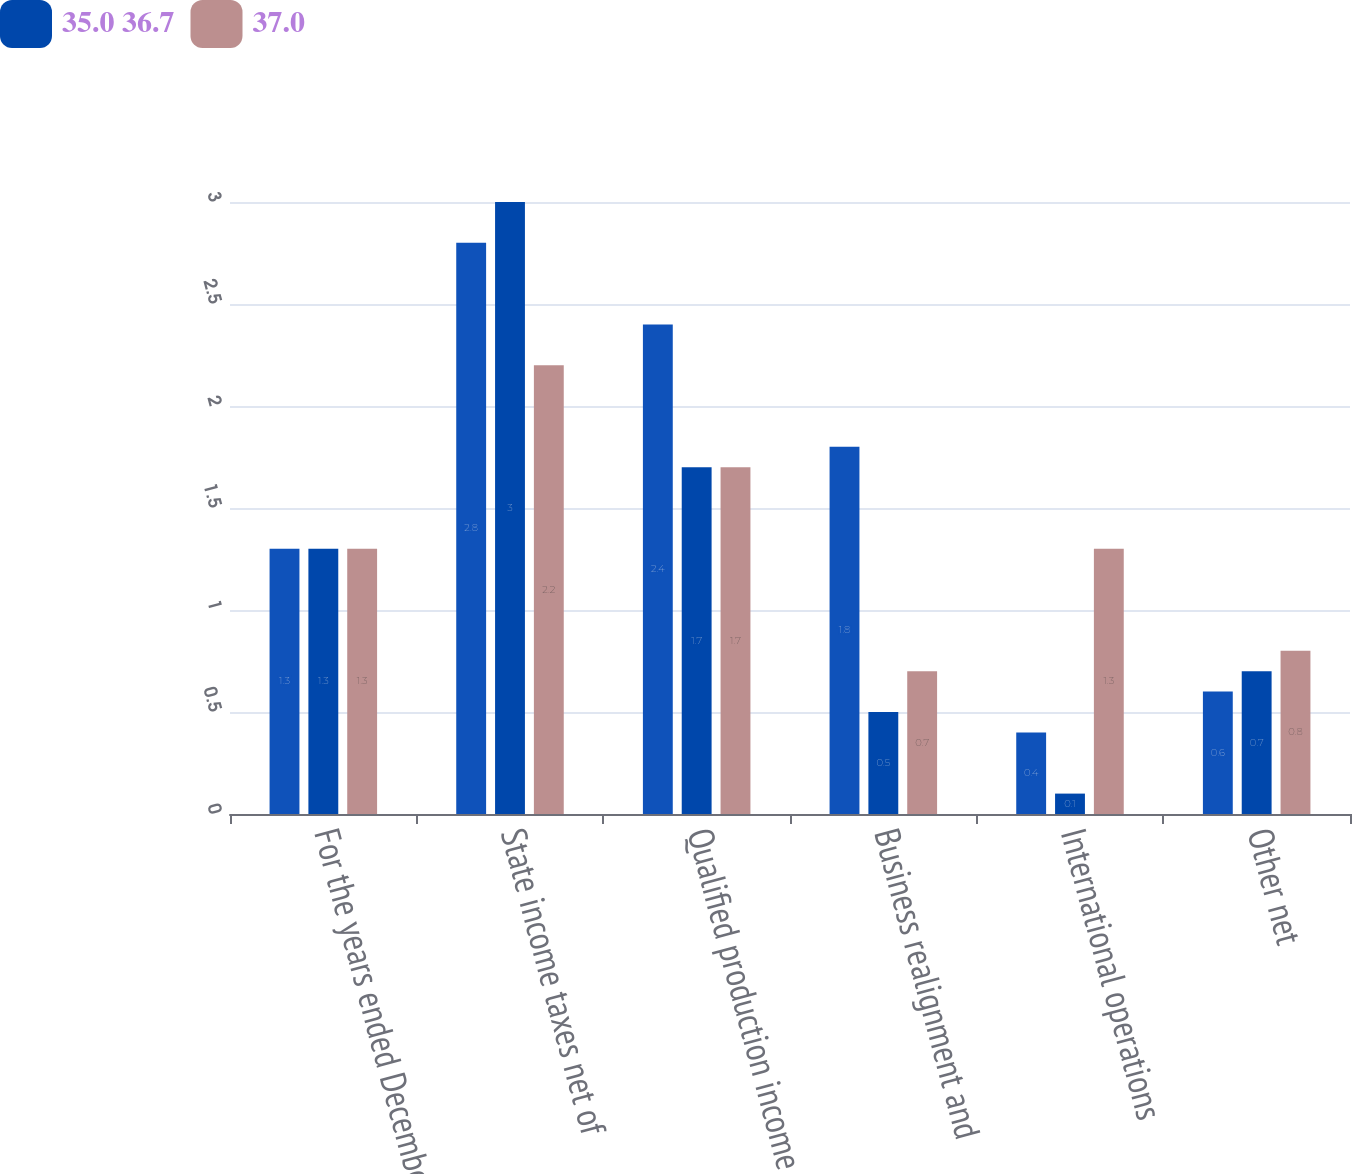Convert chart. <chart><loc_0><loc_0><loc_500><loc_500><stacked_bar_chart><ecel><fcel>For the years ended December<fcel>State income taxes net of<fcel>Qualified production income<fcel>Business realignment and<fcel>International operations<fcel>Other net<nl><fcel>nan<fcel>1.3<fcel>2.8<fcel>2.4<fcel>1.8<fcel>0.4<fcel>0.6<nl><fcel>35.0 36.7<fcel>1.3<fcel>3<fcel>1.7<fcel>0.5<fcel>0.1<fcel>0.7<nl><fcel>37.0<fcel>1.3<fcel>2.2<fcel>1.7<fcel>0.7<fcel>1.3<fcel>0.8<nl></chart> 